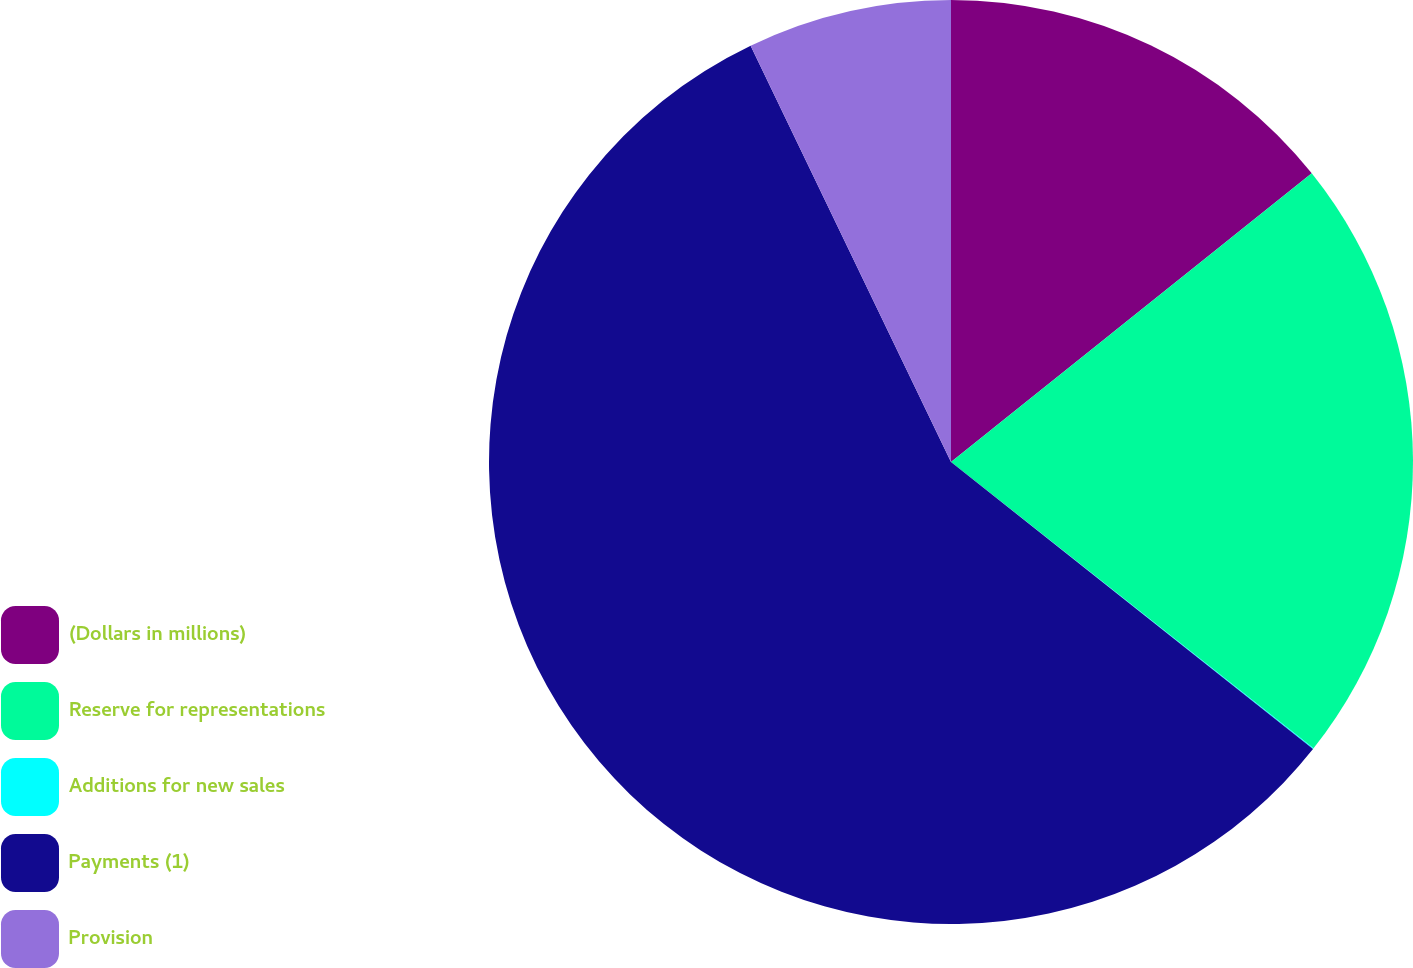Convert chart to OTSL. <chart><loc_0><loc_0><loc_500><loc_500><pie_chart><fcel>(Dollars in millions)<fcel>Reserve for representations<fcel>Additions for new sales<fcel>Payments (1)<fcel>Provision<nl><fcel>14.26%<fcel>21.38%<fcel>0.03%<fcel>57.19%<fcel>7.14%<nl></chart> 